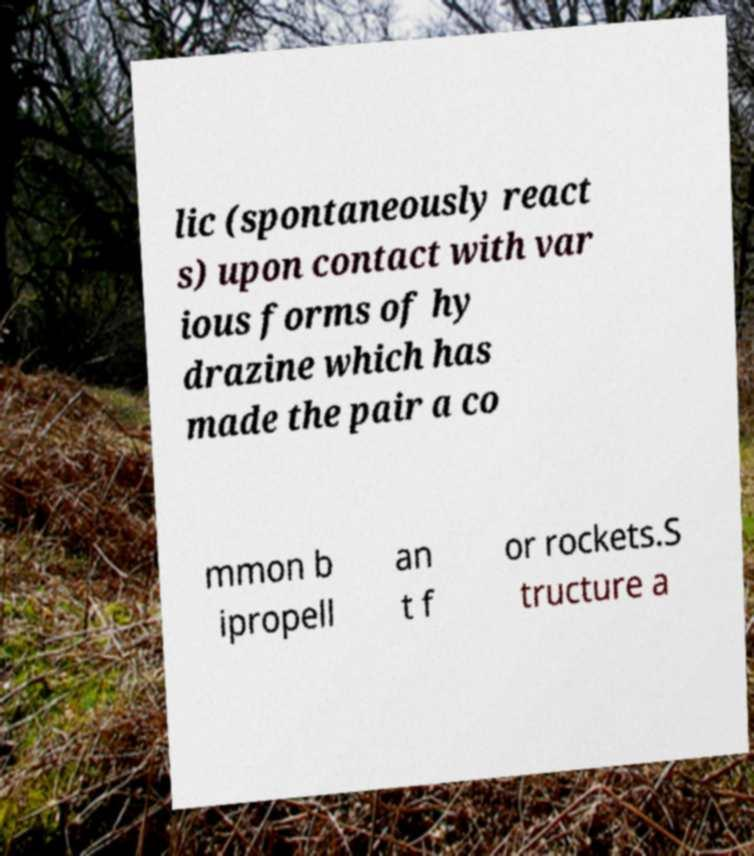Could you assist in decoding the text presented in this image and type it out clearly? lic (spontaneously react s) upon contact with var ious forms of hy drazine which has made the pair a co mmon b ipropell an t f or rockets.S tructure a 